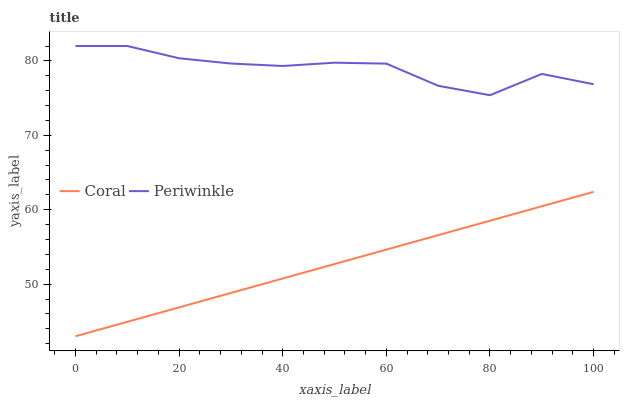Does Coral have the minimum area under the curve?
Answer yes or no. Yes. Does Periwinkle have the maximum area under the curve?
Answer yes or no. Yes. Does Periwinkle have the minimum area under the curve?
Answer yes or no. No. Is Coral the smoothest?
Answer yes or no. Yes. Is Periwinkle the roughest?
Answer yes or no. Yes. Is Periwinkle the smoothest?
Answer yes or no. No. Does Coral have the lowest value?
Answer yes or no. Yes. Does Periwinkle have the lowest value?
Answer yes or no. No. Does Periwinkle have the highest value?
Answer yes or no. Yes. Is Coral less than Periwinkle?
Answer yes or no. Yes. Is Periwinkle greater than Coral?
Answer yes or no. Yes. Does Coral intersect Periwinkle?
Answer yes or no. No. 